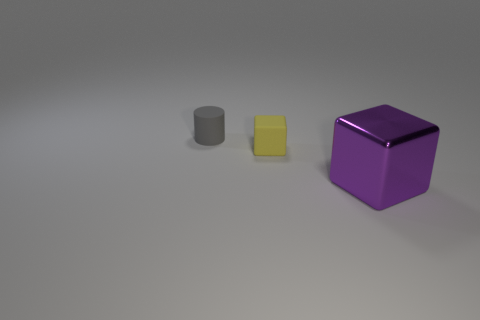Add 1 tiny gray cylinders. How many objects exist? 4 Subtract all blocks. How many objects are left? 1 Add 3 yellow things. How many yellow things exist? 4 Subtract 0 green cubes. How many objects are left? 3 Subtract all blue balls. Subtract all big purple metal cubes. How many objects are left? 2 Add 1 purple blocks. How many purple blocks are left? 2 